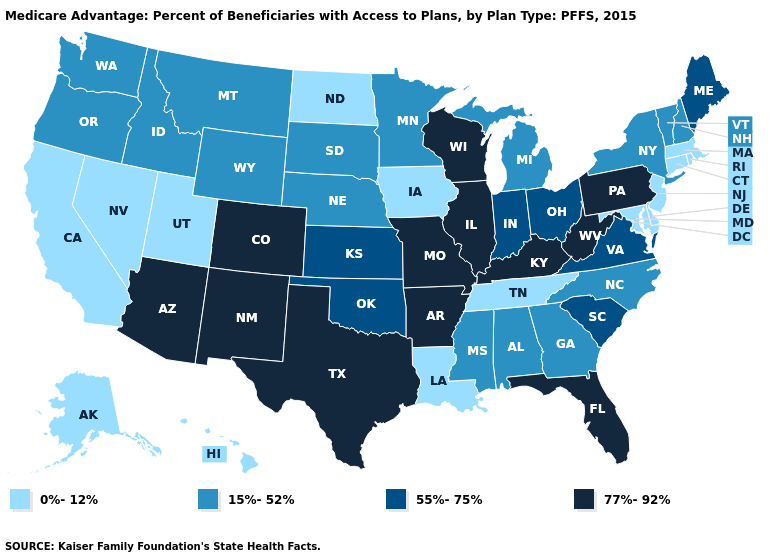What is the highest value in the MidWest ?
Quick response, please. 77%-92%. Does Vermont have the highest value in the Northeast?
Be succinct. No. Does Virginia have the highest value in the South?
Keep it brief. No. Name the states that have a value in the range 77%-92%?
Quick response, please. Colorado, Florida, Illinois, Kentucky, Missouri, New Mexico, Pennsylvania, Texas, Wisconsin, West Virginia, Arkansas, Arizona. What is the highest value in states that border Wisconsin?
Answer briefly. 77%-92%. Does the first symbol in the legend represent the smallest category?
Be succinct. Yes. Which states have the lowest value in the USA?
Short answer required. California, Connecticut, Delaware, Hawaii, Iowa, Louisiana, Massachusetts, Maryland, North Dakota, New Jersey, Nevada, Rhode Island, Alaska, Tennessee, Utah. Does Virginia have a lower value than Kentucky?
Give a very brief answer. Yes. What is the lowest value in states that border Delaware?
Answer briefly. 0%-12%. Which states have the lowest value in the USA?
Give a very brief answer. California, Connecticut, Delaware, Hawaii, Iowa, Louisiana, Massachusetts, Maryland, North Dakota, New Jersey, Nevada, Rhode Island, Alaska, Tennessee, Utah. Name the states that have a value in the range 15%-52%?
Concise answer only. Georgia, Idaho, Michigan, Minnesota, Mississippi, Montana, North Carolina, Nebraska, New Hampshire, New York, Oregon, South Dakota, Vermont, Washington, Wyoming, Alabama. Does North Dakota have a lower value than Delaware?
Quick response, please. No. What is the value of Wyoming?
Quick response, please. 15%-52%. Does the first symbol in the legend represent the smallest category?
Keep it brief. Yes. Name the states that have a value in the range 55%-75%?
Concise answer only. Indiana, Kansas, Maine, Ohio, Oklahoma, South Carolina, Virginia. 